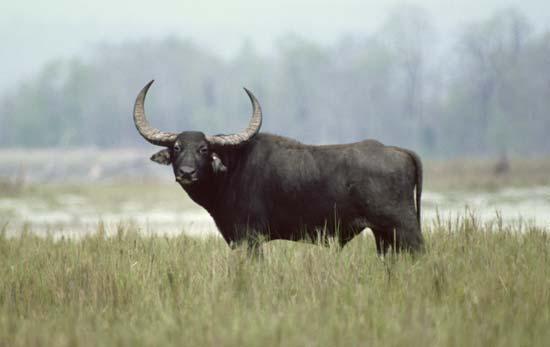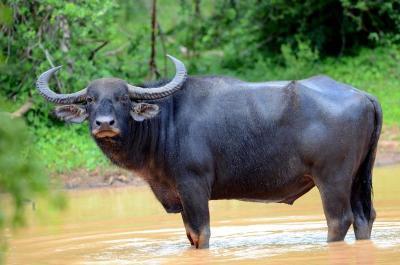The first image is the image on the left, the second image is the image on the right. Considering the images on both sides, is "At least 1 cattle is submerged to the shoulder." valid? Answer yes or no. No. 